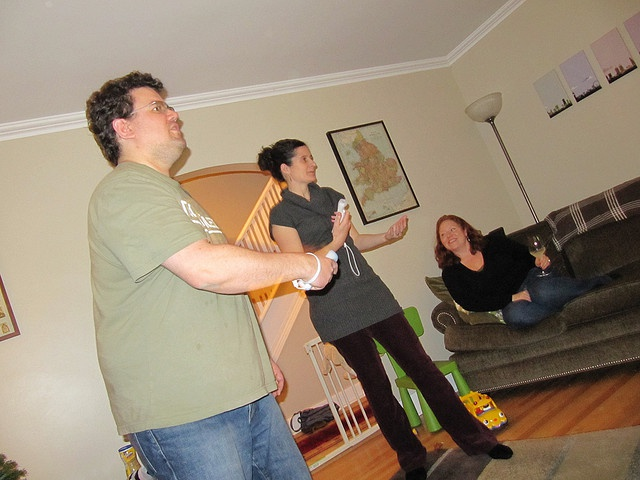Describe the objects in this image and their specific colors. I can see people in darkgray, tan, and gray tones, people in darkgray and black tones, couch in darkgray, black, and gray tones, people in darkgray, black, salmon, and maroon tones, and chair in darkgray, tan, and brown tones in this image. 